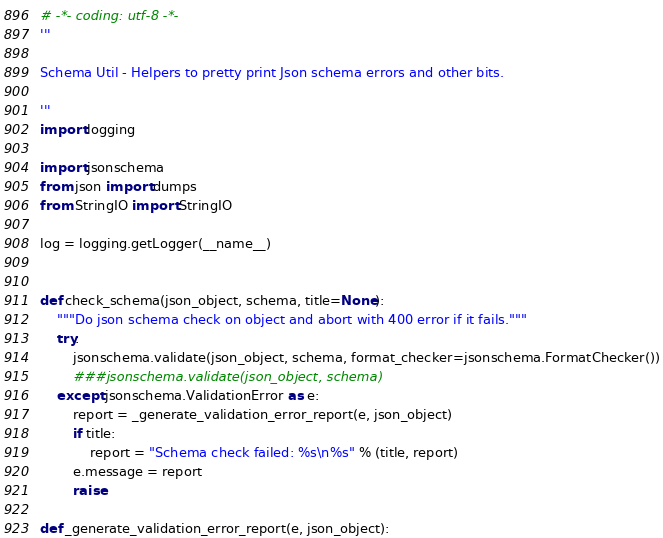Convert code to text. <code><loc_0><loc_0><loc_500><loc_500><_Python_># -*- coding: utf-8 -*-
'''

Schema Util - Helpers to pretty print Json schema errors and other bits.

'''
import logging

import jsonschema
from json import dumps
from StringIO import StringIO

log = logging.getLogger(__name__)


def check_schema(json_object, schema, title=None):
    """Do json schema check on object and abort with 400 error if it fails."""
    try:
        jsonschema.validate(json_object, schema, format_checker=jsonschema.FormatChecker())
        ###jsonschema.validate(json_object, schema)
    except jsonschema.ValidationError as e:
        report = _generate_validation_error_report(e, json_object)
        if title:
            report = "Schema check failed: %s\n%s" % (title, report)
        e.message = report
        raise

def _generate_validation_error_report(e, json_object):</code> 